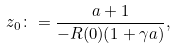<formula> <loc_0><loc_0><loc_500><loc_500>z _ { 0 } \colon = \frac { a + 1 } { - R ( 0 ) ( 1 + \gamma a ) } ,</formula> 